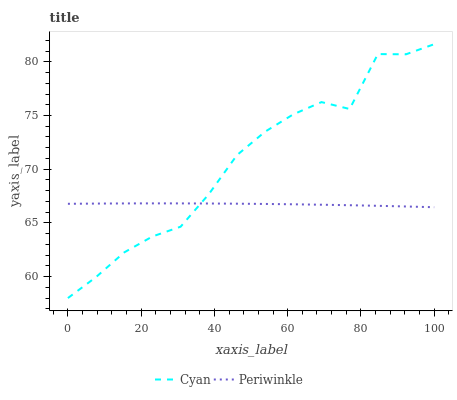Does Periwinkle have the minimum area under the curve?
Answer yes or no. Yes. Does Cyan have the maximum area under the curve?
Answer yes or no. Yes. Does Periwinkle have the maximum area under the curve?
Answer yes or no. No. Is Periwinkle the smoothest?
Answer yes or no. Yes. Is Cyan the roughest?
Answer yes or no. Yes. Is Periwinkle the roughest?
Answer yes or no. No. Does Cyan have the lowest value?
Answer yes or no. Yes. Does Periwinkle have the lowest value?
Answer yes or no. No. Does Cyan have the highest value?
Answer yes or no. Yes. Does Periwinkle have the highest value?
Answer yes or no. No. Does Periwinkle intersect Cyan?
Answer yes or no. Yes. Is Periwinkle less than Cyan?
Answer yes or no. No. Is Periwinkle greater than Cyan?
Answer yes or no. No. 